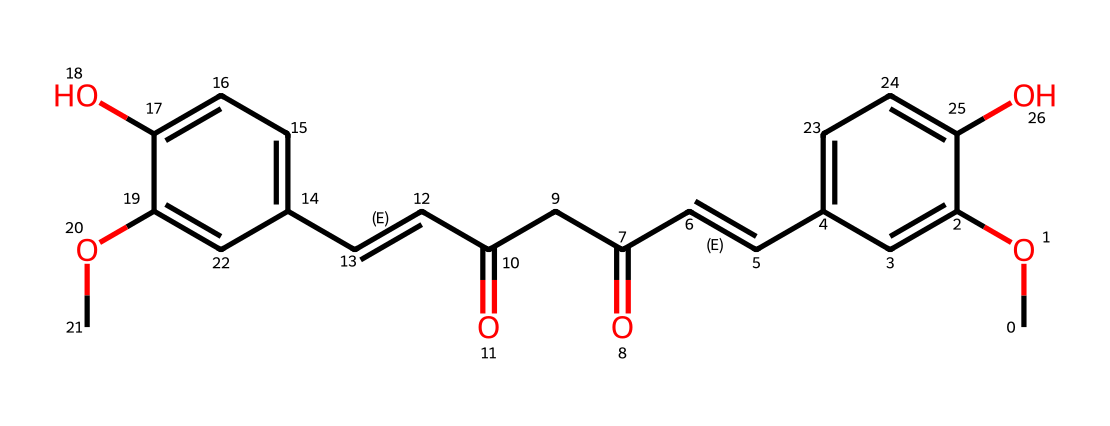What is the molecular formula of curcumin? By analyzing the atoms present in the SMILES representation, we can determine the number of carbon (C), hydrogen (H), and oxygen (O) atoms. The SMILES indicates there are 21 carbons, 20 hydrogens, and 6 oxygens, leading to the formula C21H20O6.
Answer: C21H20O6 How many aromatic rings are in the structure? Upon examining the structure, we can identify distinct aromatic rings from the alternating double bonds represented in the chemical structure. There are two phenolic groups that form two aromatic rings.
Answer: 2 What type of functional groups are present in curcumin? Looking closely at the SMILES representation, we can find hydroxyl (-OH) groups, methoxy (-OCH3) groups, and carbonyl (C=O) functional groups. These different groups indicate the complex functionality of curcumin.
Answer: hydroxyl, methoxy, carbonyl What characterizes the backbone of curcumin? The backbone of curcumin consists of a conjugated system formed by alternating double and single bonds, which can be identified in the SMILES notation. This system helps in understanding the reactivity and stability of the compound in biochemical contexts.
Answer: conjugated system Which part of the curcumin structure is likely responsible for its antioxidant properties? The structure's phenolic hydroxyl groups (identified in the SMILES) are known to contribute to antioxidant capabilities due to their ability to donate hydrogen atoms and stabilize free radicals.
Answer: phenolic hydroxyl groups How many double bonds are present in the curcumin structure? By analyzing the connections in the SMILES, we can count the double bonds, which are denoted by "=" signs. There are six double bonds present in the curcumin structure.
Answer: 6 What is the significance of the methoxy groups in curcumin? The methoxy groups (-OCH3) in the curcumin structure can influence its solubility and bioavailability, as these groups can interact favorably with polar solvents and biological membranes, enhancing the compound's efficacy.
Answer: enhance solubility and bioavailability 